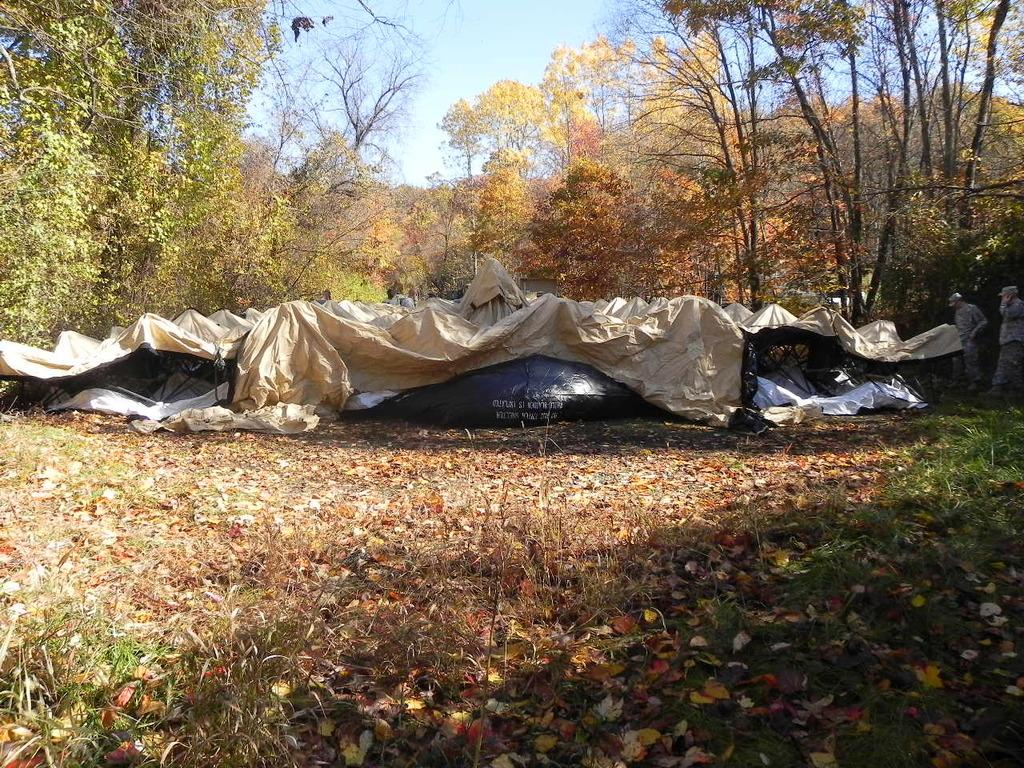What type of location is depicted in the image? There is a land in the image. What structures can be seen on the land? There are tents on the land. What activity is taking place on the land? There are men handling rent clothes on the land. What type of vegetation is visible in the background of the image? There are trees in the background of the image. What else can be seen in the background of the image? The sky is visible in the background of the image. What color is the pet that is shaking paint in the image? There is no pet or paint present in the image. 